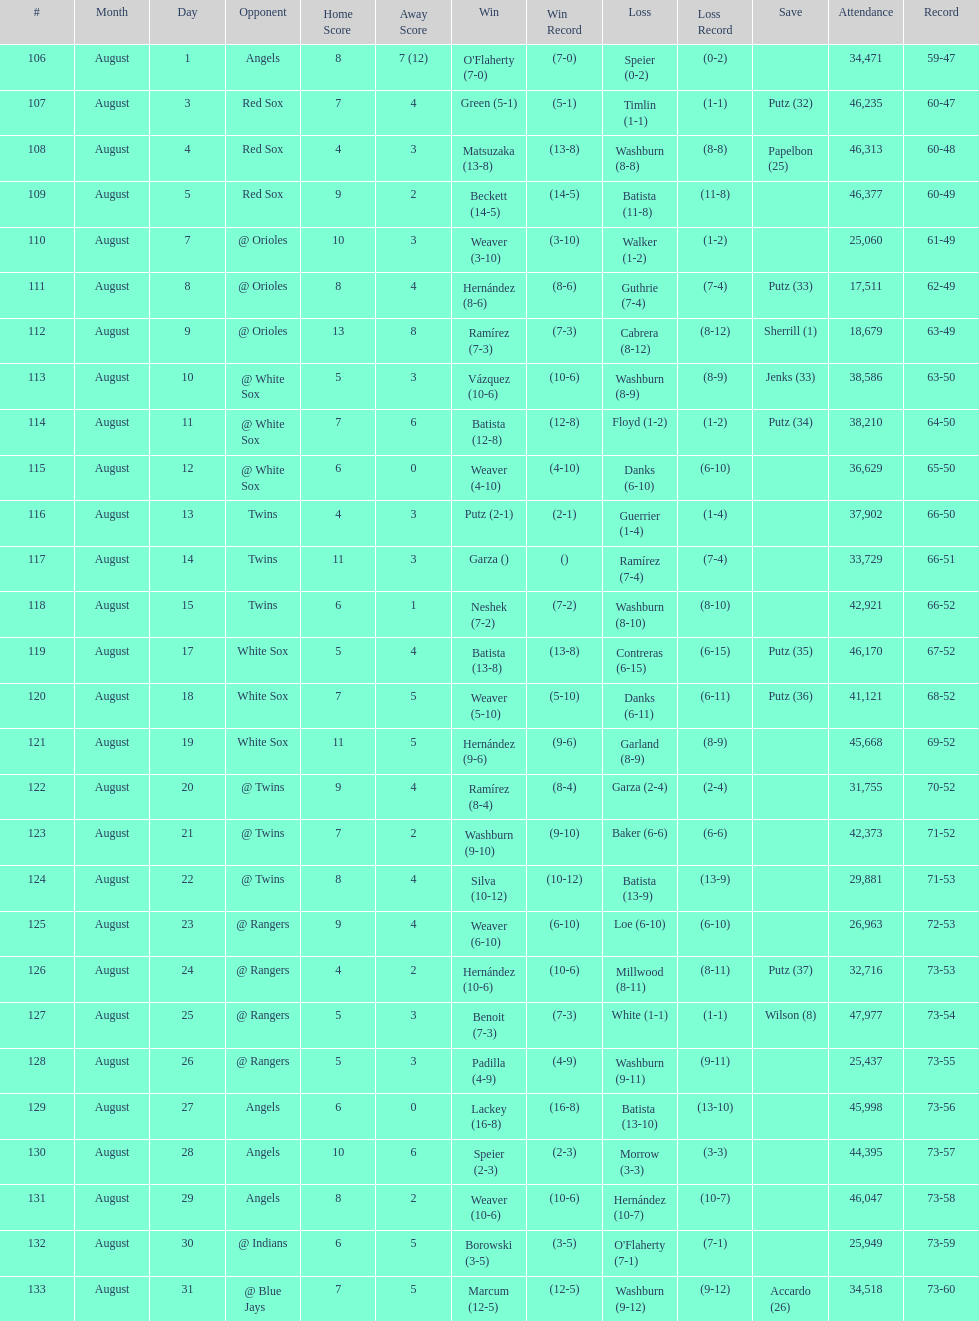Number of wins during stretch 5. 